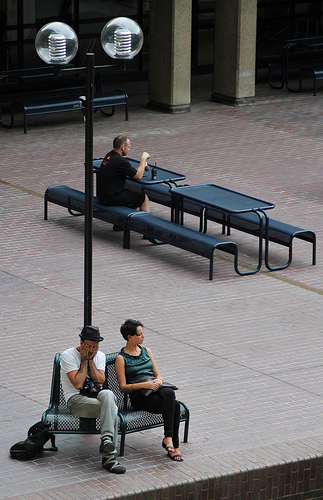Please provide a short description for this region: [0.25, 0.11, 0.44, 0.64]. A solitary, black metal lamp post stands prominently in this section, acting as a quaint urban fixture amidst a busy public area. 